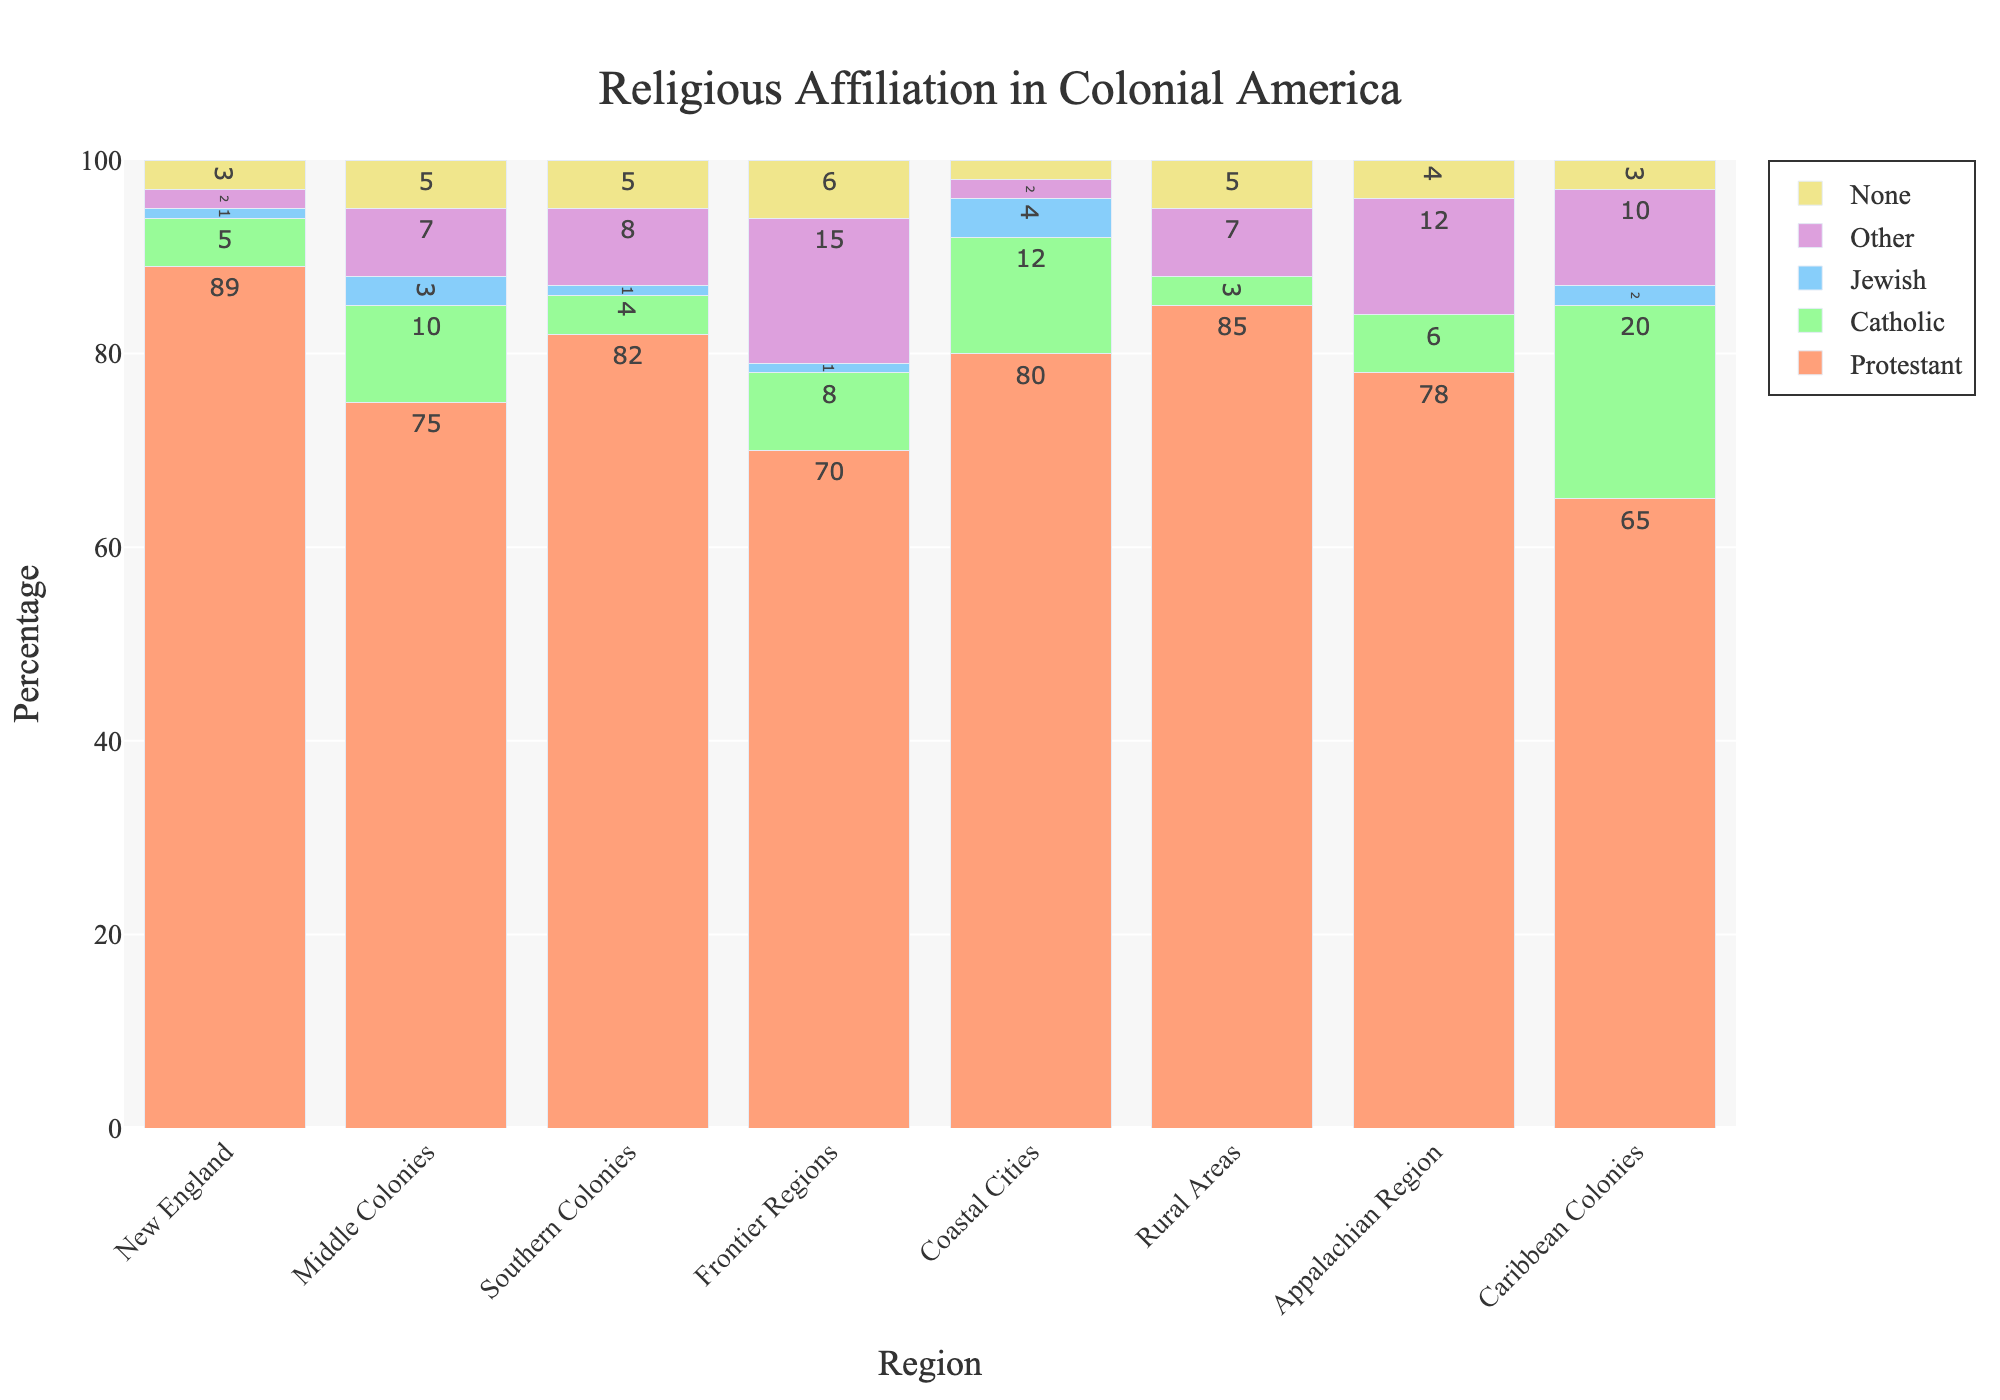What's the percentage of Protestant affiliation in the Caribbean Colonies? Look at the bar corresponding to the Caribbean Colonies for the Protestant percentage; it is labeled 65%.
Answer: 65% Which region has the highest percentage of Catholic affiliation? Compare the heights of the bars for Catholic affiliation across all regions; the Coastal Cities have the highest Catholic percentage, labeled 12%.
Answer: Coastal Cities What is the difference in the percentage of people with no religious affiliation between the Frontier Regions and New England? Subtract the None percentage of New England (3%) from that of the Frontier Regions (6%): 6% - 3% = 3%.
Answer: 3% Which region has the lowest percentage of Jewish affiliation? Compare the heights of the bars for Jewish affiliation; the Rural Areas and Appalachian Region both have 0% Jewish affiliation.
Answer: Rural Areas, Appalachian Region What is the combined percentage of other religious affiliations for the Southern Colonies and the Caribbean Colonies? Add the percentages of Other affiliations in the Southern Colonies and Caribbean Colonies: 8% + 10% = 18%.
Answer: 18% Which region has the smallest percentage of Protestant affiliation, and by how much does it differ from the region with the highest percentage of Protestant affiliation? The Caribbean Colonies have the smallest Protestant percentage (65%), and New England has the highest (89%). The difference is 89% - 65% = 24%.
Answer: Caribbean Colonies, 24% What's the average percentage of people with no religious affiliation across all regions? Add the None percentages across all regions and divide by the number of regions: (3% + 5% + 5% + 6% + 2% + 5% + 4% + 3%) / 8 = 33% / 8 = 4.125%.
Answer: 4.125% What is the total percentage of Protestant and Catholic affiliations in the Appalachain Region? Add the Protestant and Catholic percentages in the Appalachian Region: 78% + 6% = 84%.
Answer: 84% Which region shows the most balanced distribution among the five religious categories? Look for the region where the heights of the bars are more evenly distributed. The Middle Colonies have a relatively balanced distribution with notable values in each category.
Answer: Middle Colonies In which region is the percentage of Other religious affiliations the highest, and what is its value? Look at the heights of the bars for Other religious affiliations. The Frontier Regions have the highest value, labeled 15%.
Answer: Frontier Regions, 15% 